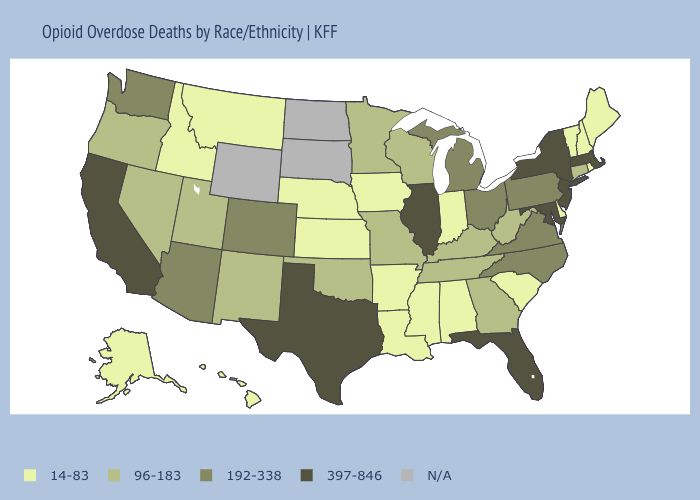What is the lowest value in the South?
Answer briefly. 14-83. What is the value of South Carolina?
Concise answer only. 14-83. What is the value of Connecticut?
Keep it brief. 96-183. What is the value of Rhode Island?
Write a very short answer. 14-83. Name the states that have a value in the range 96-183?
Answer briefly. Connecticut, Georgia, Kentucky, Minnesota, Missouri, Nevada, New Mexico, Oklahoma, Oregon, Tennessee, Utah, West Virginia, Wisconsin. Name the states that have a value in the range N/A?
Answer briefly. North Dakota, South Dakota, Wyoming. What is the value of Massachusetts?
Be succinct. 397-846. What is the highest value in the West ?
Concise answer only. 397-846. What is the value of South Carolina?
Give a very brief answer. 14-83. Name the states that have a value in the range 397-846?
Keep it brief. California, Florida, Illinois, Maryland, Massachusetts, New Jersey, New York, Texas. What is the value of North Carolina?
Give a very brief answer. 192-338. What is the lowest value in the MidWest?
Short answer required. 14-83. 